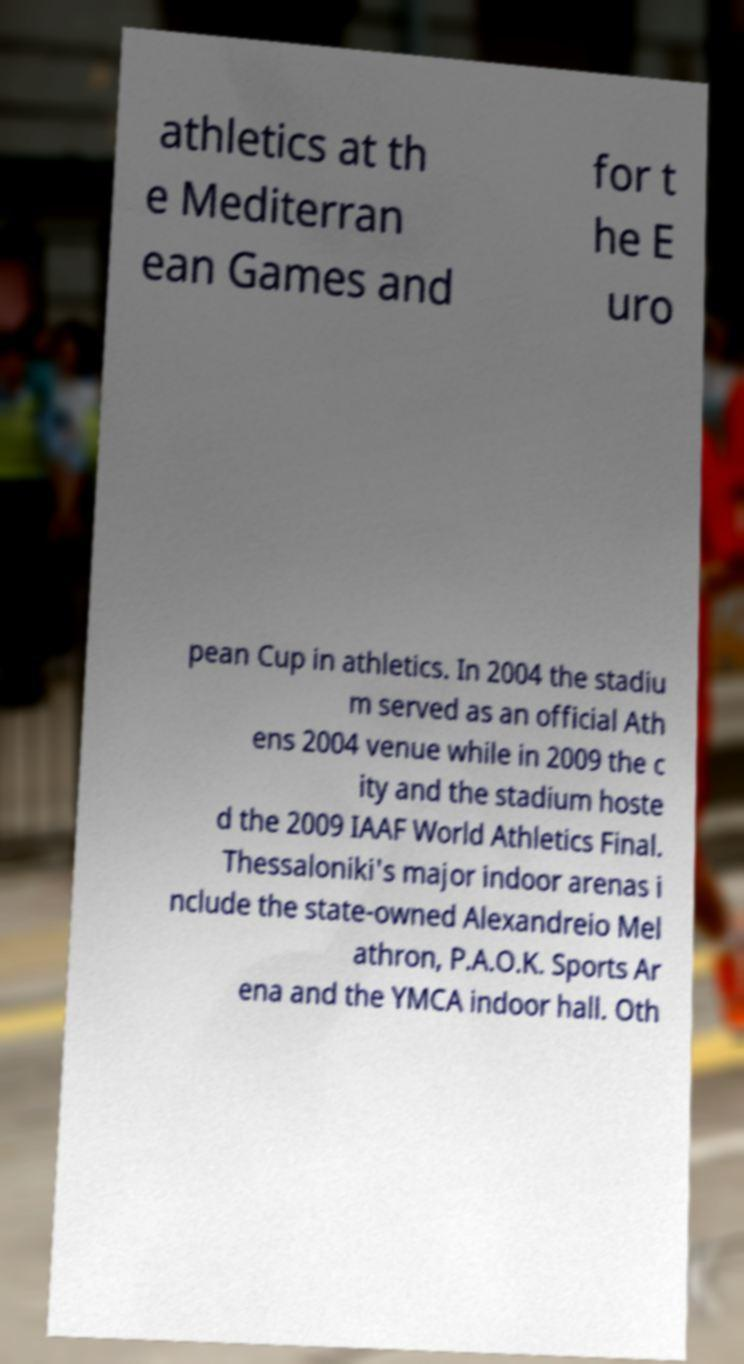Can you read and provide the text displayed in the image?This photo seems to have some interesting text. Can you extract and type it out for me? athletics at th e Mediterran ean Games and for t he E uro pean Cup in athletics. In 2004 the stadiu m served as an official Ath ens 2004 venue while in 2009 the c ity and the stadium hoste d the 2009 IAAF World Athletics Final. Thessaloniki's major indoor arenas i nclude the state-owned Alexandreio Mel athron, P.A.O.K. Sports Ar ena and the YMCA indoor hall. Oth 